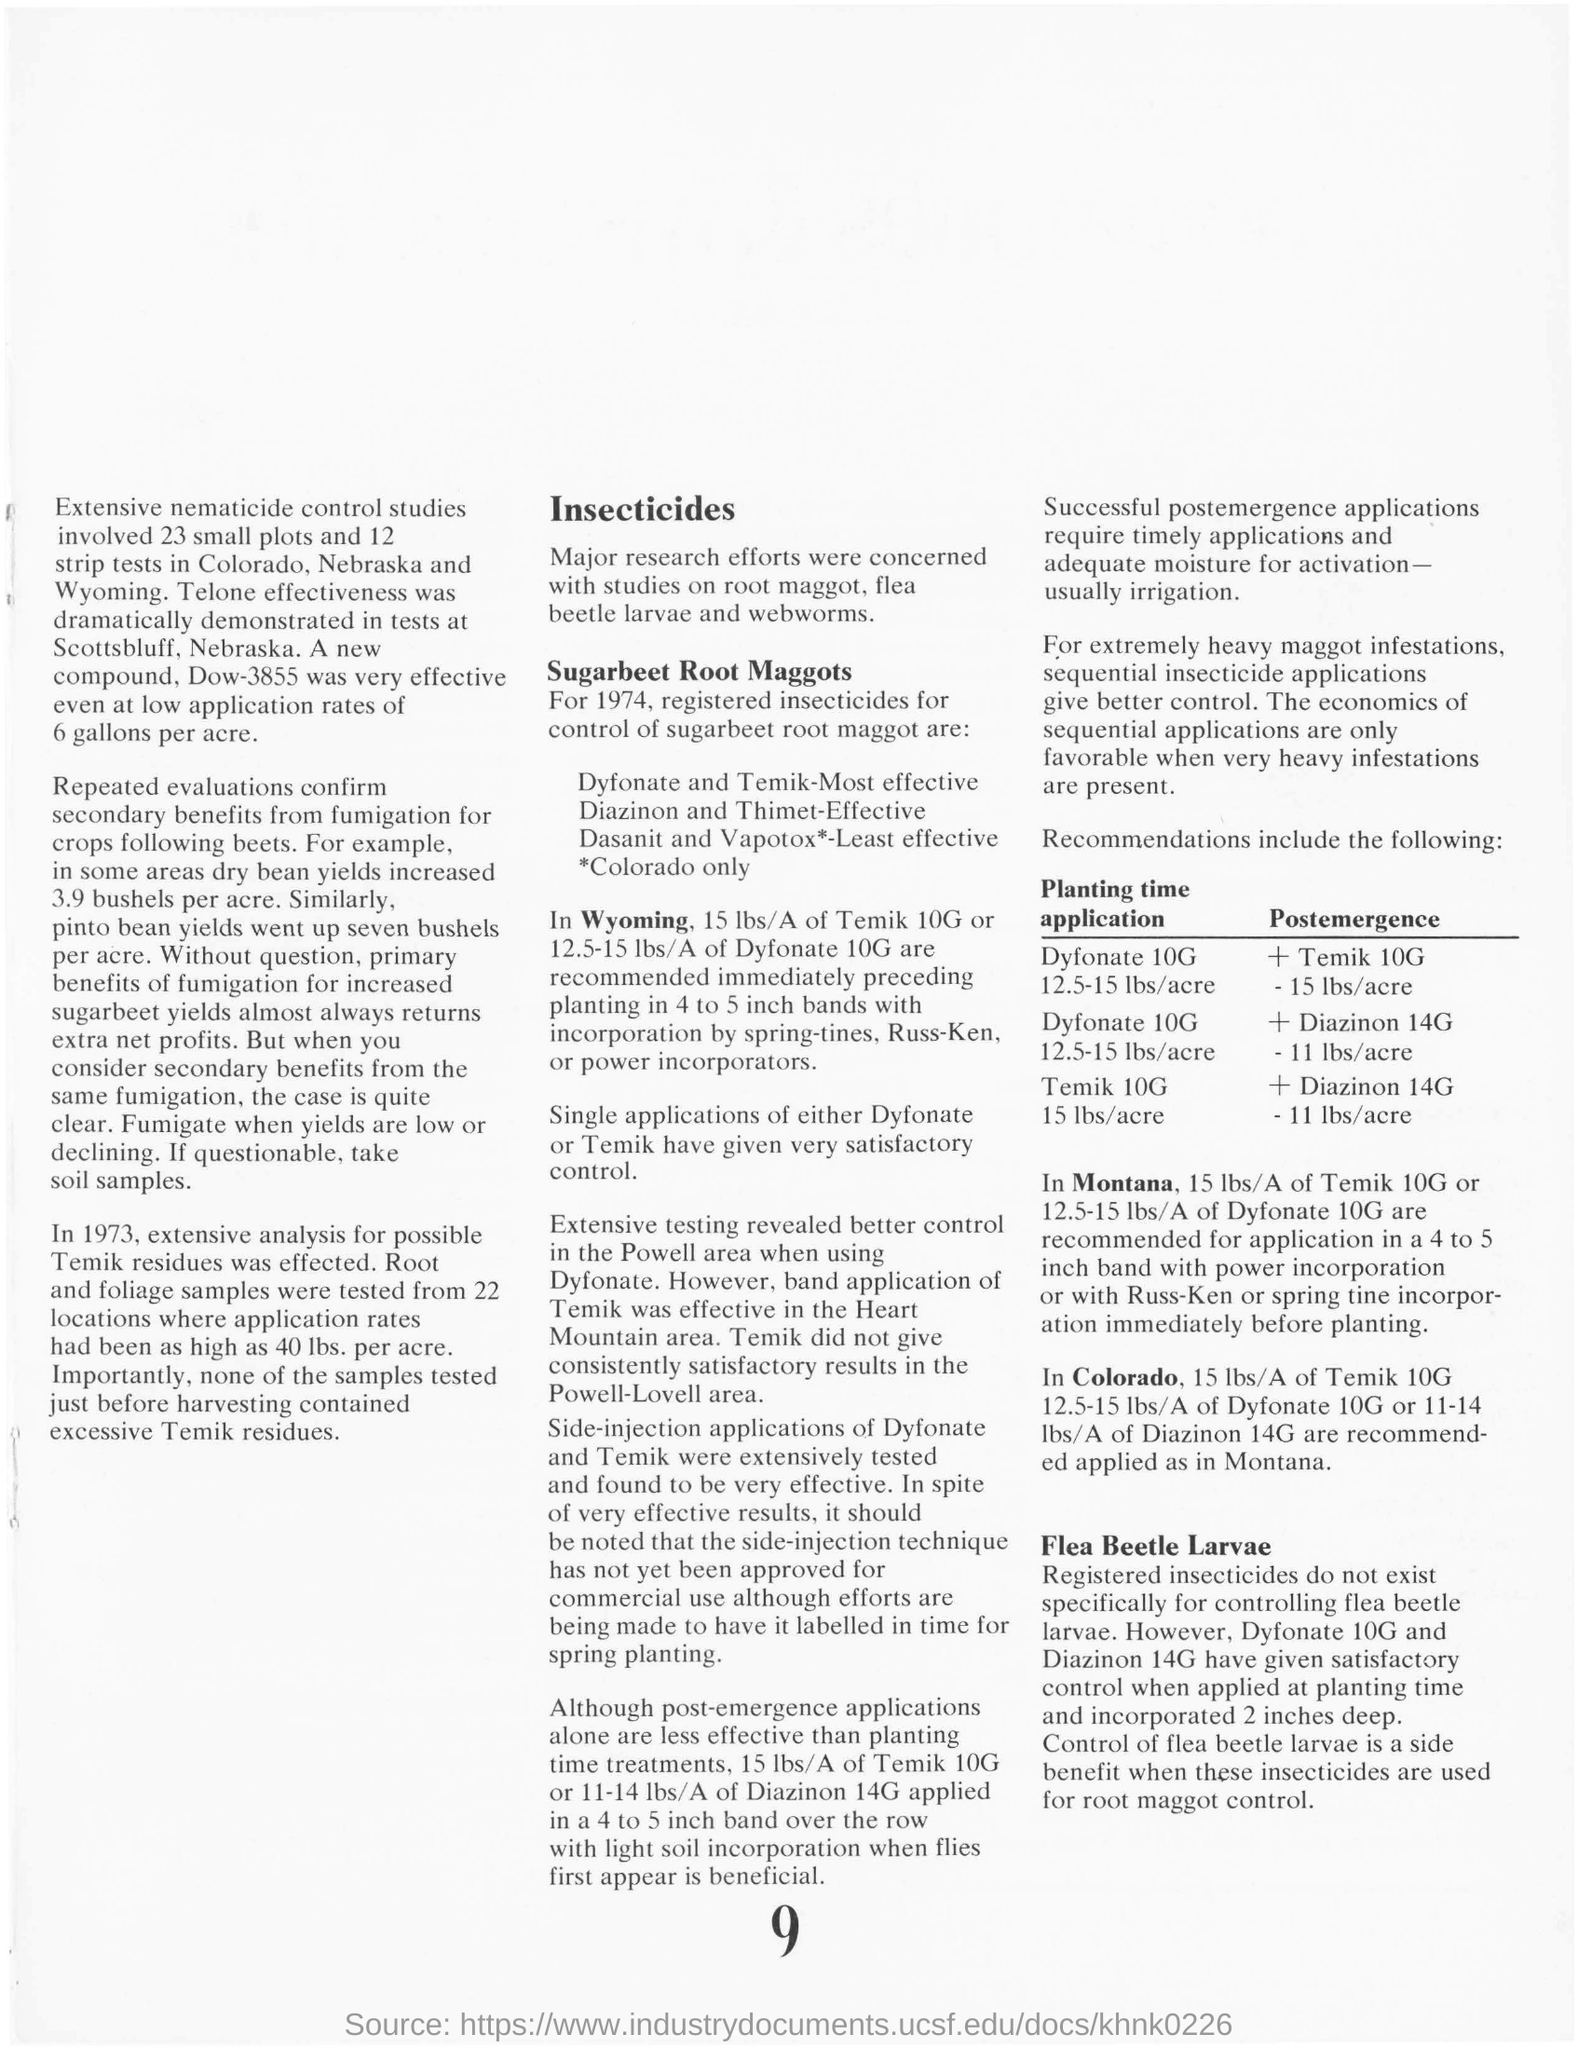List a handful of essential elements in this visual. In the Powell area, Dyfonate has been proven to provide better control of insects compared to other insecticides. Dow-3855 is a new compound that has demonstrated effectiveness even at low application rates. The title at the top of the second column is 'Insecticides.' 